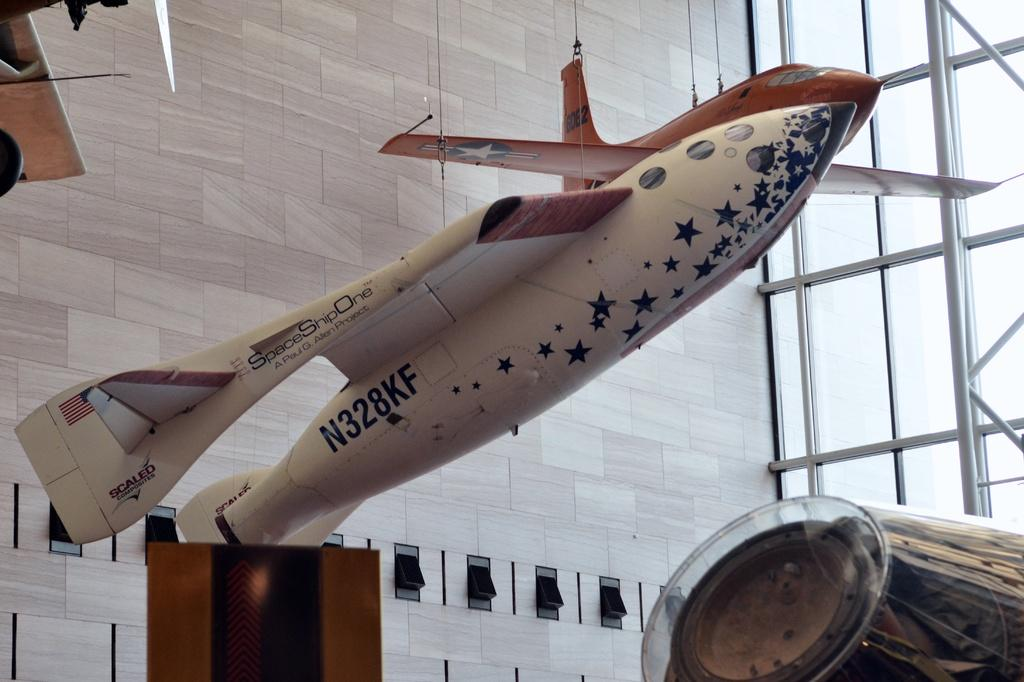<image>
Describe the image concisely. Spaceshipone airplane that is up in the air for decorations in a building 